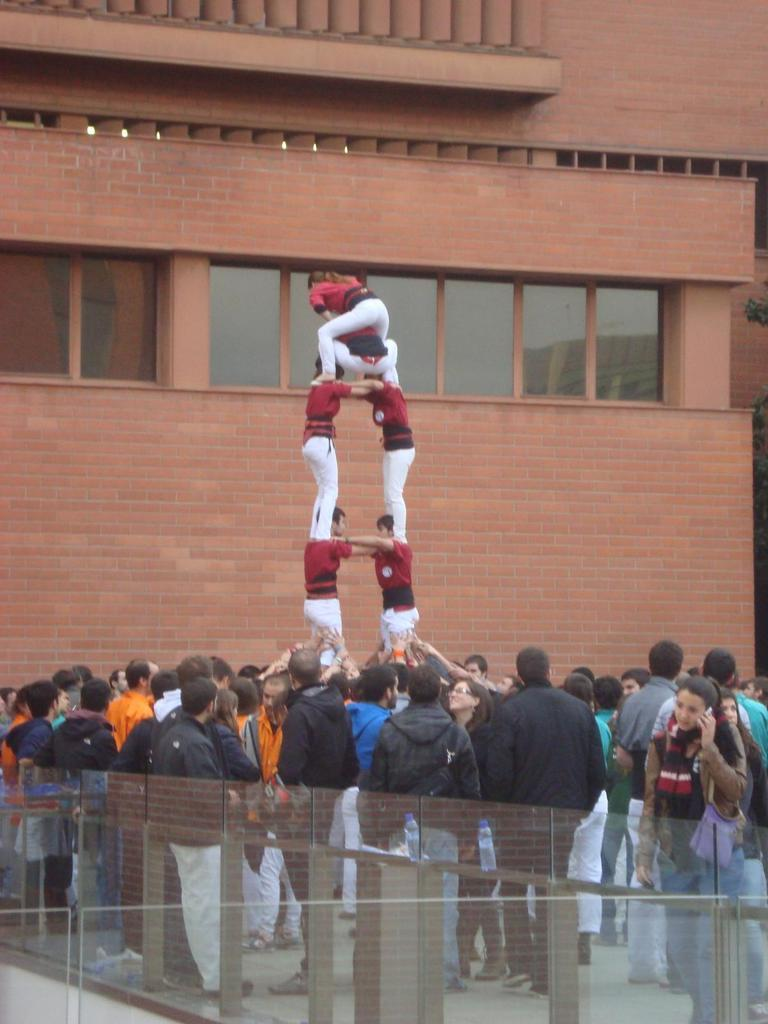What are the people in the image doing? The people in the image are on a path. What can be seen near the path in the image? There is a glass railing in the image. What is visible in the background of the image? There is a building visible in the background of the image. What type of vegetation is on the right side of the image? There is a tree on the right side of the image. What type of wool is being spun by the people in the image? There is no wool or spinning activity present in the image; the people are simply on a path. 